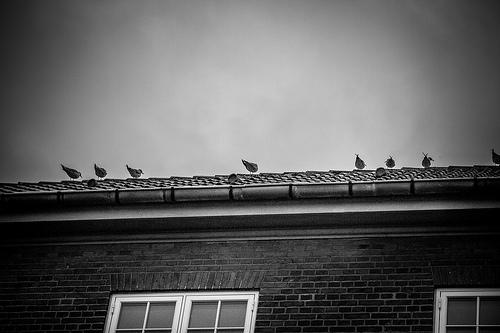Question: how is this picture presented?
Choices:
A. Black and white.
B. Without color.
C. With a filter.
D. Grayscale.
Answer with the letter. Answer: D Question: where are the birds?
Choices:
A. In the trees.
B. Flying south for the winter.
C. In their cages.
D. Roof.
Answer with the letter. Answer: D Question: how are the birds facing?
Choices:
A. The other way.
B. Facing the left.
C. Away from the picture.
D. Towards the sun.
Answer with the letter. Answer: C Question: what is the weather like?
Choices:
A. Brisk.
B. Humid.
C. It's raining.
D. Cloudy.
Answer with the letter. Answer: D Question: what is the house made of?
Choices:
A. Adobe.
B. Wood.
C. Ice.
D. Brick.
Answer with the letter. Answer: D 